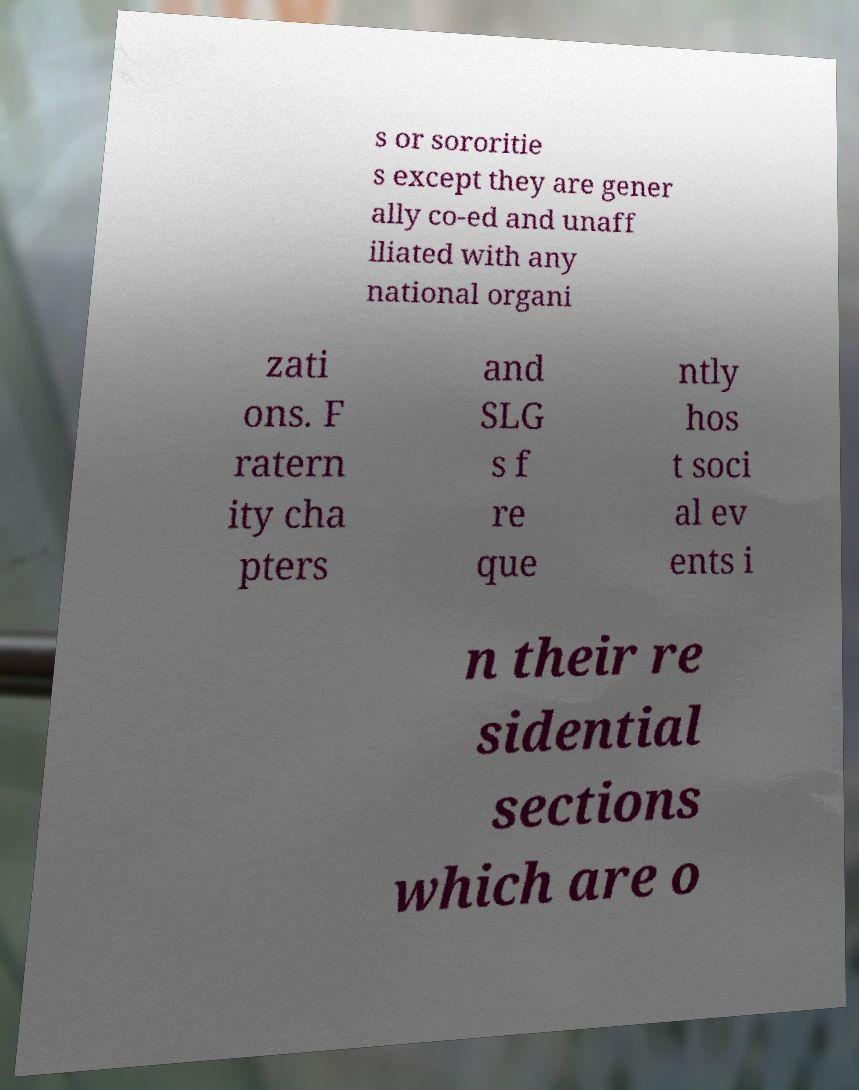Can you accurately transcribe the text from the provided image for me? s or sororitie s except they are gener ally co-ed and unaff iliated with any national organi zati ons. F ratern ity cha pters and SLG s f re que ntly hos t soci al ev ents i n their re sidential sections which are o 